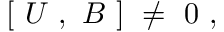Convert formula to latex. <formula><loc_0><loc_0><loc_500><loc_500>[ \ U \ , \ B \ ] \ \ne \ 0 \ ,</formula> 